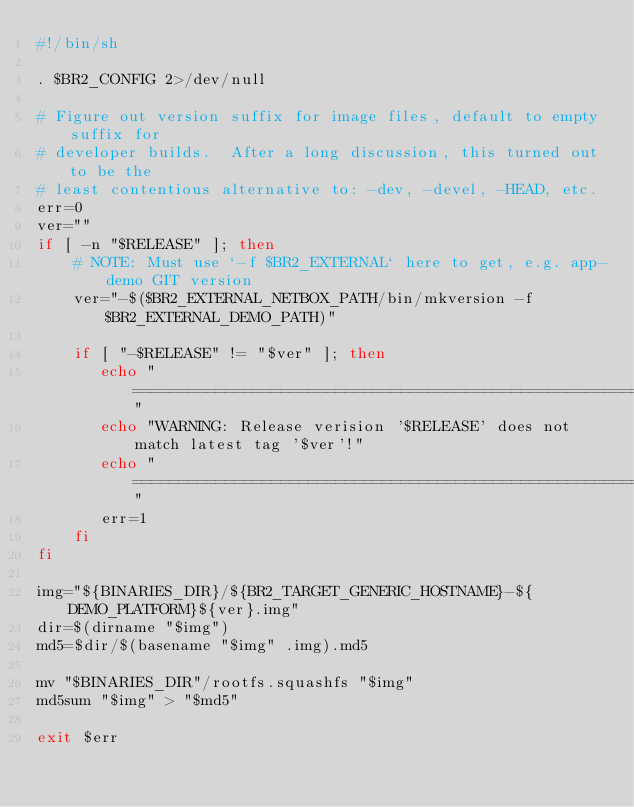Convert code to text. <code><loc_0><loc_0><loc_500><loc_500><_Bash_>#!/bin/sh

. $BR2_CONFIG 2>/dev/null

# Figure out version suffix for image files, default to empty suffix for
# developer builds.  After a long discussion, this turned out to be the
# least contentious alternative to: -dev, -devel, -HEAD, etc.
err=0
ver=""
if [ -n "$RELEASE" ]; then
    # NOTE: Must use `-f $BR2_EXTERNAL` here to get, e.g. app-demo GIT version
    ver="-$($BR2_EXTERNAL_NETBOX_PATH/bin/mkversion -f $BR2_EXTERNAL_DEMO_PATH)"

    if [ "-$RELEASE" != "$ver" ]; then
       echo "==============================================================================="
       echo "WARNING: Release verision '$RELEASE' does not match latest tag '$ver'!"
       echo "==============================================================================="
       err=1
    fi
fi

img="${BINARIES_DIR}/${BR2_TARGET_GENERIC_HOSTNAME}-${DEMO_PLATFORM}${ver}.img"
dir=$(dirname "$img")
md5=$dir/$(basename "$img" .img).md5

mv "$BINARIES_DIR"/rootfs.squashfs "$img"
md5sum "$img" > "$md5"

exit $err
</code> 